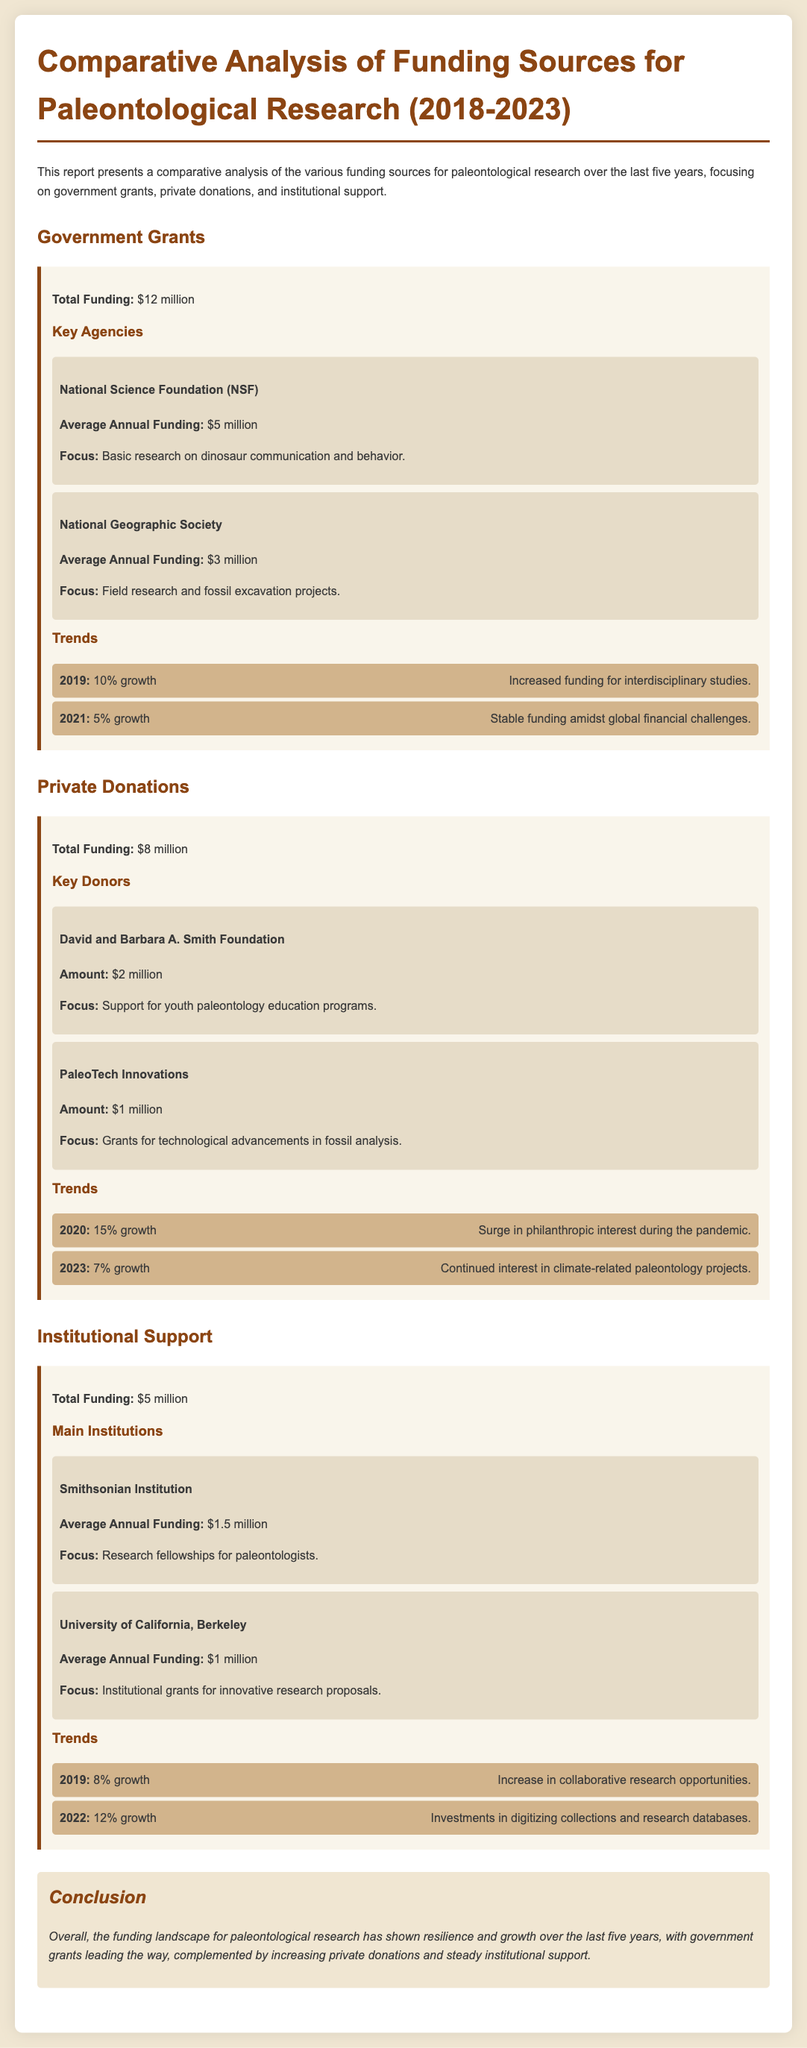what is the total funding from government grants? The total funding from government grants is explicitly stated in the document as $12 million.
Answer: $12 million who is the key agency that provides the highest average annual funding? The document lists the National Science Foundation (NSF) as providing the highest average annual funding of $5 million.
Answer: National Science Foundation (NSF) what was the percentage growth in private donations in 2020? According to the trends in the document, private donations saw a 15% growth in 2020.
Answer: 15% how much total funding does institutional support provide? The document indicates that total funding from institutional support is $5 million.
Answer: $5 million which institution provides the lowest average annual funding? The document specifies that the University of California, Berkeley provides the lowest average annual funding at $1 million.
Answer: University of California, Berkeley what is the focus of the David and Barbara A. Smith Foundation? The document states that the focus is on support for youth paleontology education programs.
Answer: Support for youth paleontology education programs what trend occurred in government grants in 2021? The document notes a 5% growth in government grants in 2021 amid global financial challenges.
Answer: 5% growth how has the overall funding landscape for paleontological research changed over the last five years? The conclusion section summarizes the funding landscape as showing resilience and growth over the past five years.
Answer: Resilience and growth what was the total funding from private donations? The document asserts that total funding from private donations is $8 million.
Answer: $8 million 